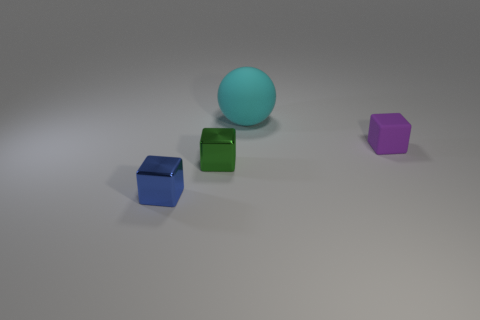Add 3 small blocks. How many small blocks exist? 6 Add 4 tiny red metal things. How many objects exist? 8 Subtract all purple cubes. How many cubes are left? 2 Subtract all small rubber cubes. How many cubes are left? 2 Subtract 0 purple cylinders. How many objects are left? 4 Subtract all balls. How many objects are left? 3 Subtract 1 balls. How many balls are left? 0 Subtract all blue spheres. Subtract all gray cubes. How many spheres are left? 1 Subtract all red cylinders. How many blue cubes are left? 1 Subtract all cyan rubber objects. Subtract all big yellow things. How many objects are left? 3 